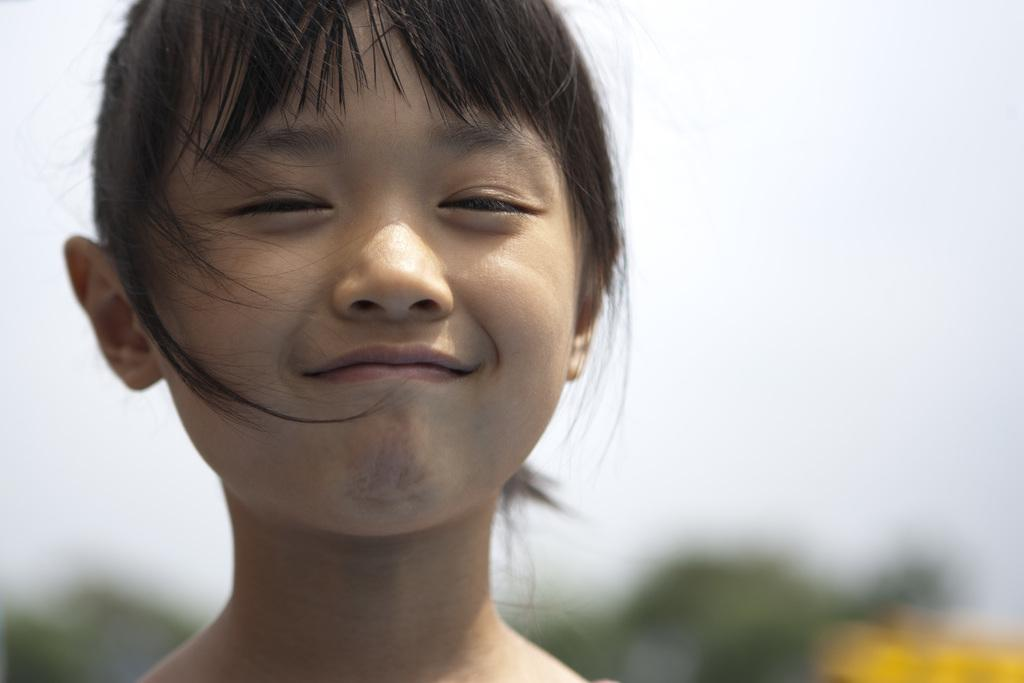What is the main subject of the image? The main subject of the image is a girl's face. What expression does the girl have in the image? The girl is smiling in the image. What type of drink is the girl holding in the image? There is no drink present in the image; it only shows the girl's face. 